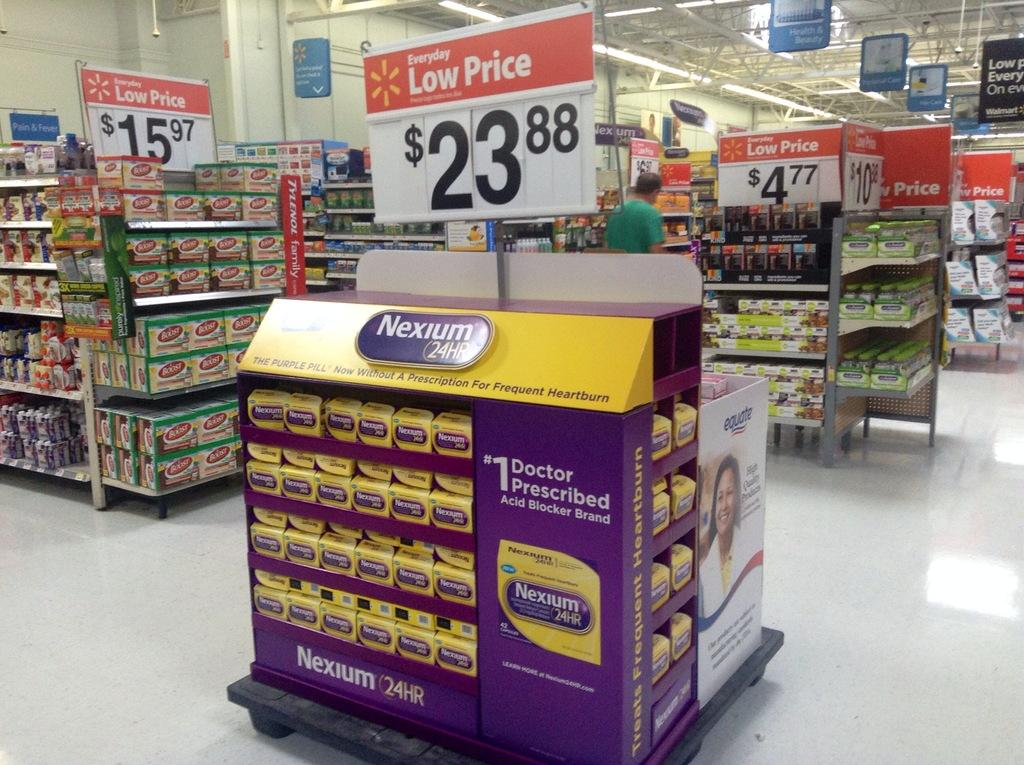<image>
Present a compact description of the photo's key features. Section of Walmart that shows Nexium 24 HR Tablets with a price of 23.88. 